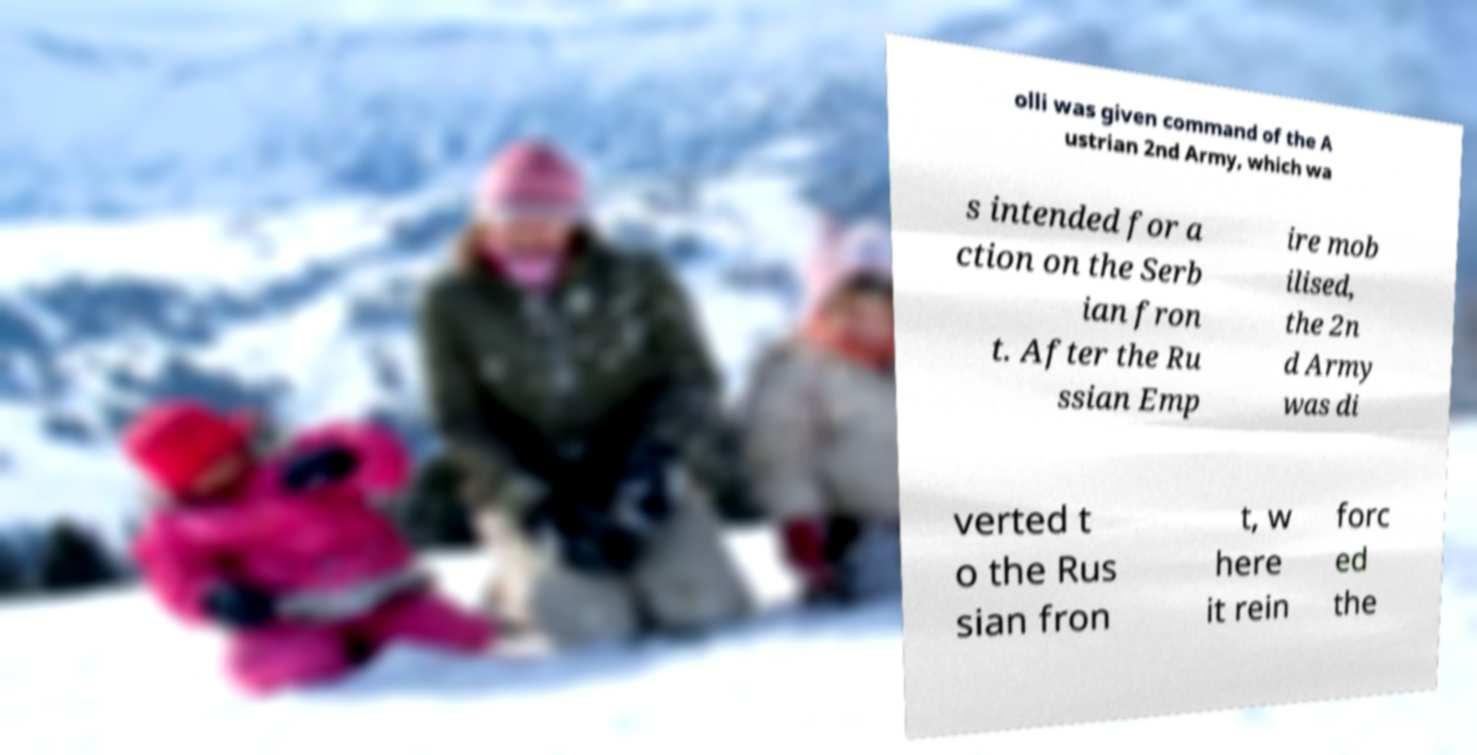Can you read and provide the text displayed in the image?This photo seems to have some interesting text. Can you extract and type it out for me? olli was given command of the A ustrian 2nd Army, which wa s intended for a ction on the Serb ian fron t. After the Ru ssian Emp ire mob ilised, the 2n d Army was di verted t o the Rus sian fron t, w here it rein forc ed the 